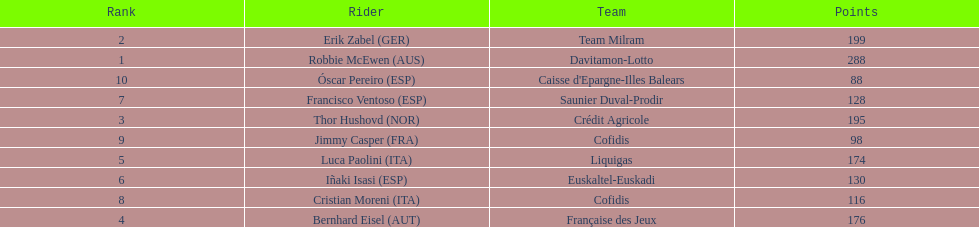Parse the table in full. {'header': ['Rank', 'Rider', 'Team', 'Points'], 'rows': [['2', 'Erik Zabel\xa0(GER)', 'Team Milram', '199'], ['1', 'Robbie McEwen\xa0(AUS)', 'Davitamon-Lotto', '288'], ['10', 'Óscar Pereiro\xa0(ESP)', "Caisse d'Epargne-Illes Balears", '88'], ['7', 'Francisco Ventoso\xa0(ESP)', 'Saunier Duval-Prodir', '128'], ['3', 'Thor Hushovd\xa0(NOR)', 'Crédit Agricole', '195'], ['9', 'Jimmy Casper\xa0(FRA)', 'Cofidis', '98'], ['5', 'Luca Paolini\xa0(ITA)', 'Liquigas', '174'], ['6', 'Iñaki Isasi\xa0(ESP)', 'Euskaltel-Euskadi', '130'], ['8', 'Cristian Moreni\xa0(ITA)', 'Cofidis', '116'], ['4', 'Bernhard Eisel\xa0(AUT)', 'Française des Jeux', '176']]} How many points did robbie mcewen and cristian moreni score together? 404. 